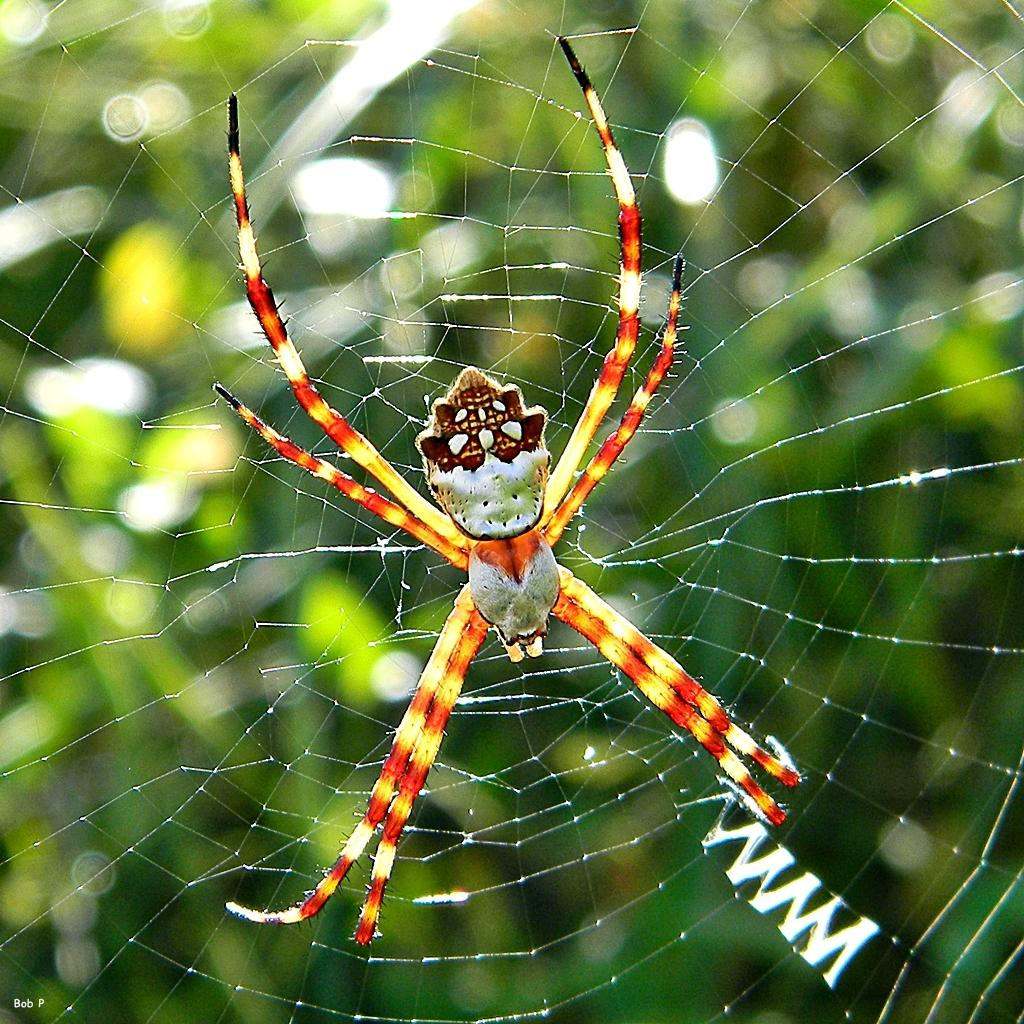What is present in the image that is associated with spiders? There is a spider web and a spider in the image. Can you describe the spider web in the image? The spider web is visible in the image. What is the tendency of the spider to manage the ground in the image? There is no indication in the image of the spider having any tendency to manage the ground. 